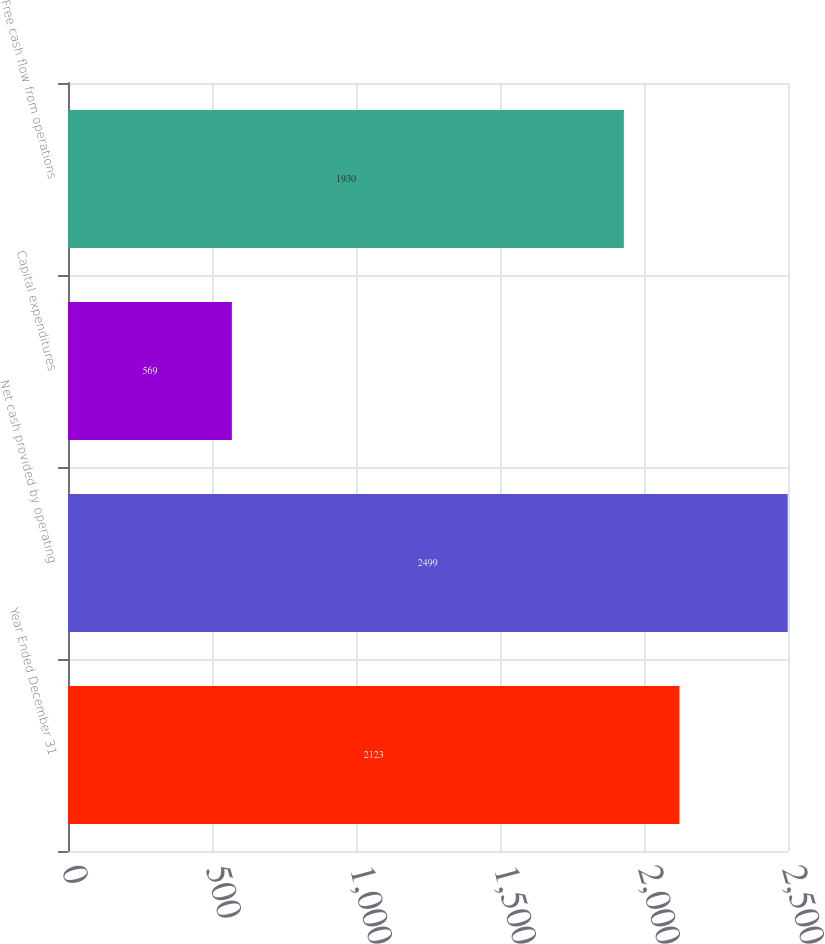Convert chart. <chart><loc_0><loc_0><loc_500><loc_500><bar_chart><fcel>Year Ended December 31<fcel>Net cash provided by operating<fcel>Capital expenditures<fcel>Free cash flow from operations<nl><fcel>2123<fcel>2499<fcel>569<fcel>1930<nl></chart> 